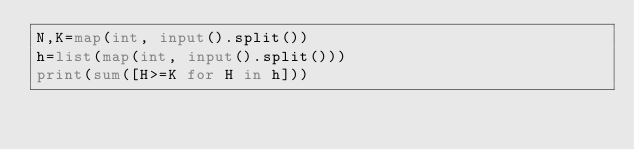<code> <loc_0><loc_0><loc_500><loc_500><_Python_>N,K=map(int, input().split())
h=list(map(int, input().split()))
print(sum([H>=K for H in h]))</code> 